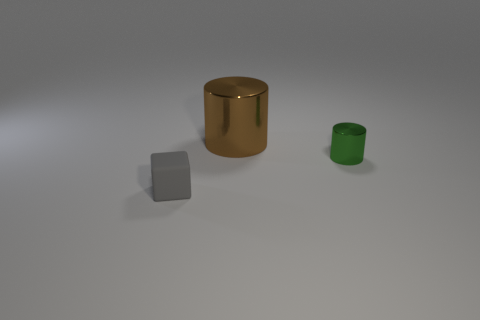Add 2 rubber blocks. How many objects exist? 5 Subtract all cubes. How many objects are left? 2 Subtract all blue balls. Subtract all brown metal cylinders. How many objects are left? 2 Add 2 brown metallic things. How many brown metallic things are left? 3 Add 2 big red balls. How many big red balls exist? 2 Subtract 0 cyan cubes. How many objects are left? 3 